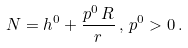Convert formula to latex. <formula><loc_0><loc_0><loc_500><loc_500>N = h ^ { 0 } + \frac { p ^ { 0 } \, R } { r } \, , \, p ^ { 0 } > 0 \, .</formula> 